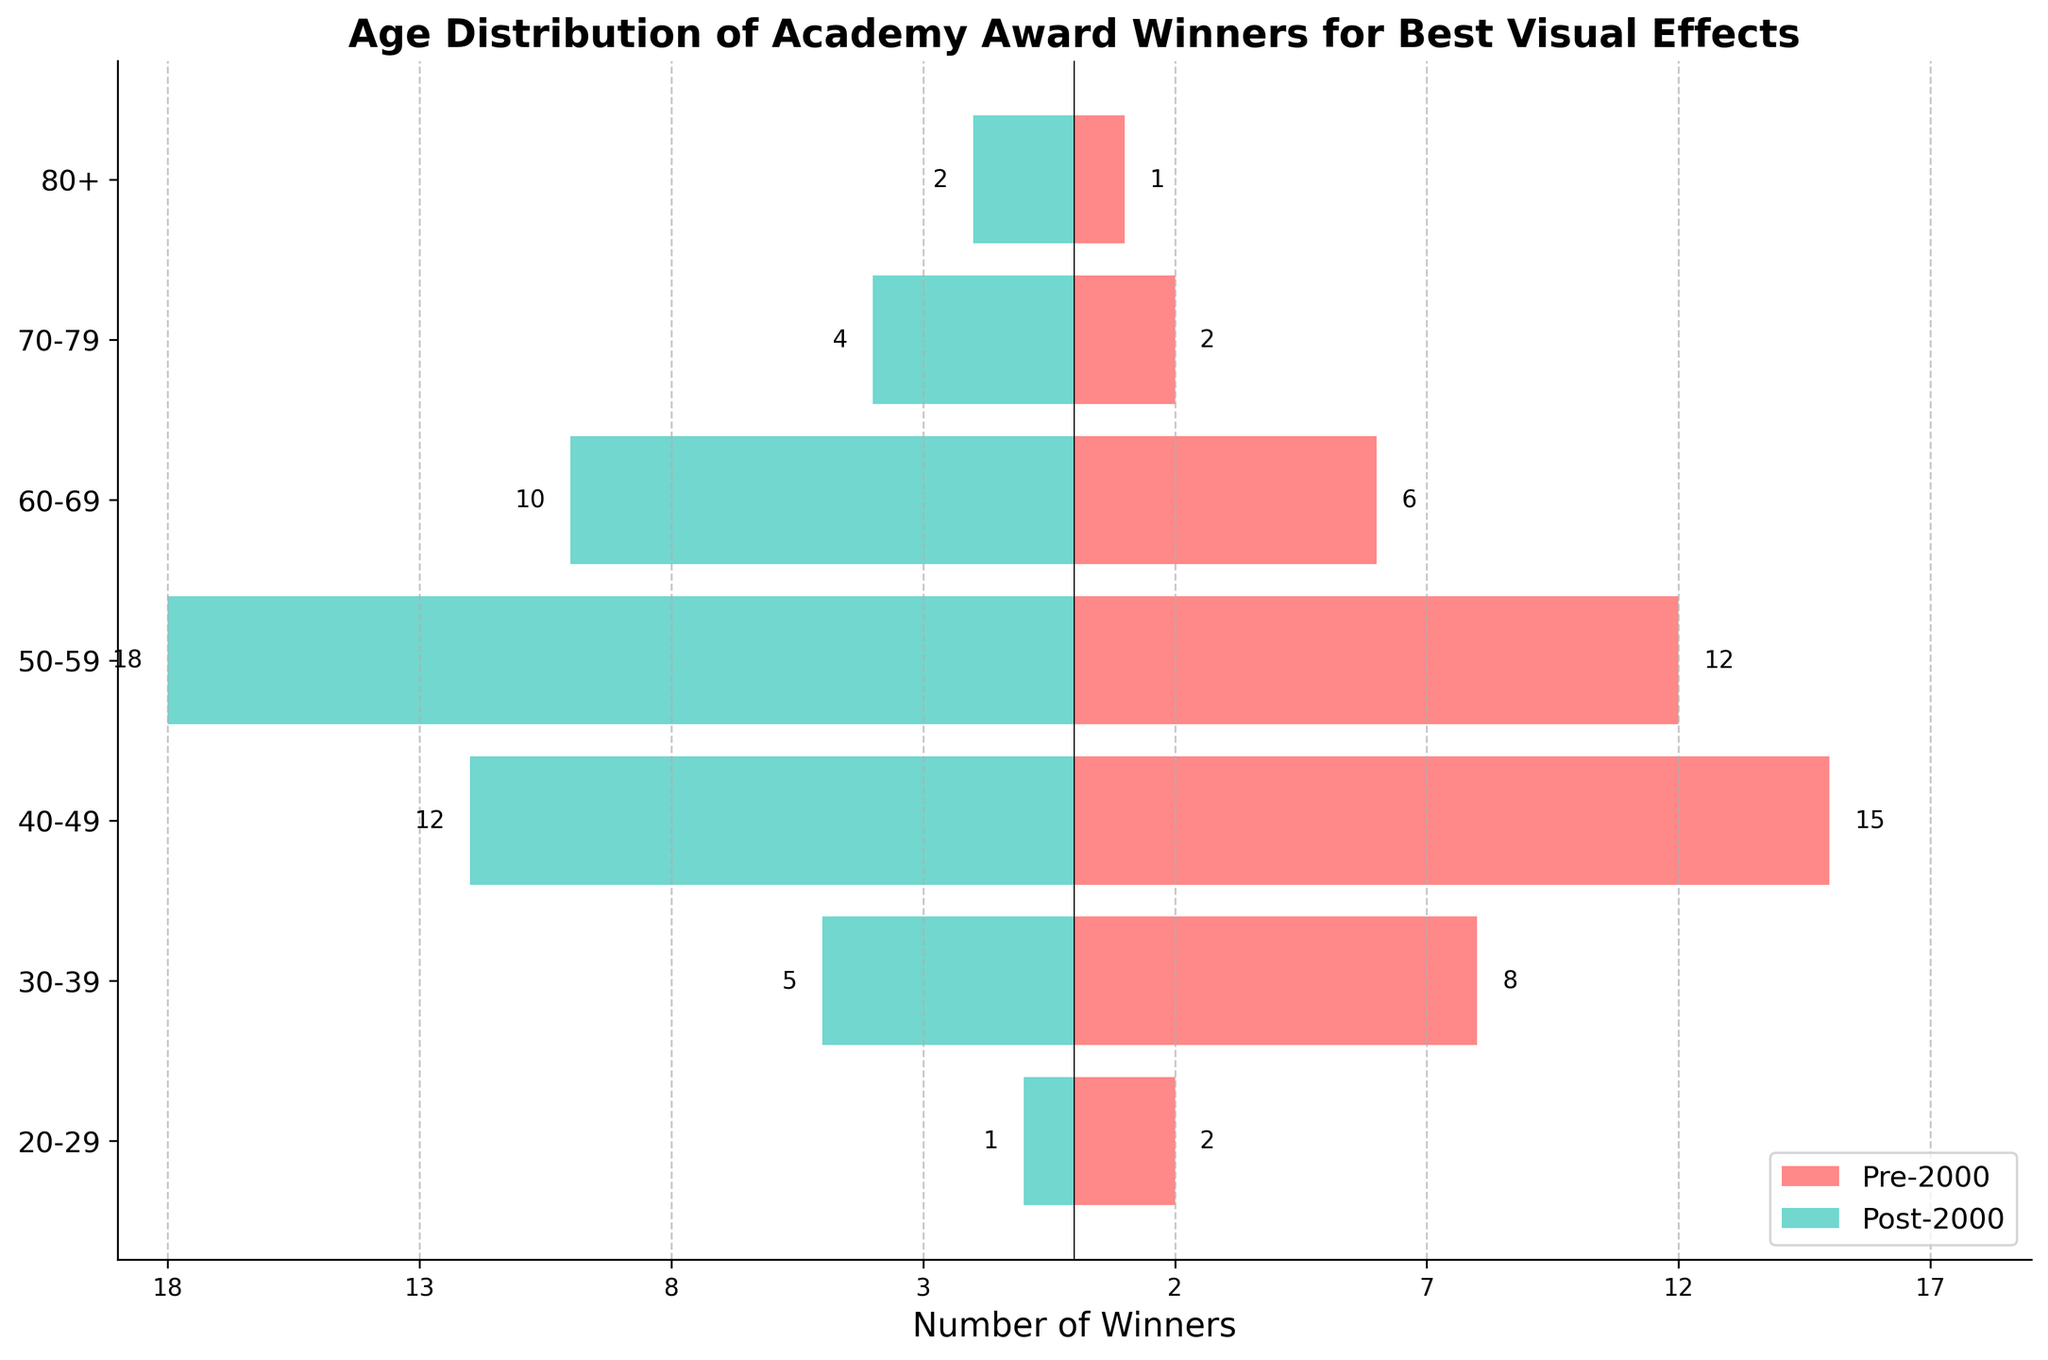What is the title of the plot? The title of the plot can be found at the top of the figure. It reads "Age Distribution of Academy Award Winners for Best Visual Effects."
Answer: Age Distribution of Academy Award Winners for Best Visual Effects Which age group had the most winners in the pre-2000 era? To find this, look at the bar lengths on the left side of the vertical axis. The age group 40-49 has the longest bar, indicating it had the most winners.
Answer: 40-49 What is the total number of winners in the post-2000 era? Sum all the values in the post-2000 data column: 1 (20-29) + 5 (30-39) + 12 (40-49) + 18 (50-59) + 10 (60-69) + 4 (70-79) + 2 (80+).
Answer: 52 How does the number of winners in the 50-59 age group compare between the two eras? Compare the length of the bars for the 50-59 age group on both sides of the vertical axis. The pre-2000 era has a bar with length 12, while the post-2000 era has a bar with length 18.
Answer: Post-2000 has 6 more winners than pre-2000 Which era had more elderly winners (age groups 70-79 and 80+ combined)? Sum the numbers in the 70-79 and 80+ age groups for both eras: Pre-2000 has 2 (70-79) + 1 (80+) = 3, and Post-2000 has 4 (70-79) + 2 (80+) = 6.
Answer: Post-2000 What is the difference in the number of winners aged 30-39 between the two eras? Subtract the number of winners in the post-2000 era from the number in the pre-2000 era for the 30-39 age group: 8 (pre-2000) - 5 (post-2000).
Answer: 3 Which age group saw the largest increase in the number of winners from pre-2000 to post-2000? To determine the largest increase, calculate the difference between the two eras for each age group: 
1 (20-29) - 2 (20-29) = -1, 
5 (30-39) - 8 (30-39) = -3, 
12 (40-49) - 15 (40-49) = -3, 
18 (50-59) - 12 (50-59) = 6, 
10 (60-69) - 6 (60-69) = 4, 
4 (70-79) - 2 (70-79) = 2, 
2 (80+) - 1 (80+) = 1. 
The largest positive difference is for the 50-59 age group.
Answer: 50-59 Which era had more winners in the 60-69 age group? Compare the bar lengths for the 60-69 age group on both sides of the vertical axis: Pre-2000 has a bar with length 6, while Post-2000 has a bar with length 10.
Answer: Post-2000 How many age groups had a decrease in winners from pre-2000 to post-2000? Identify age groups where the post-2000 bar is shorter than the pre-2000 bar: 20-29 (2 to 1), 30-39 (8 to 5), and 40-49 (15 to 12). This gives 3 age groups.
Answer: 3 